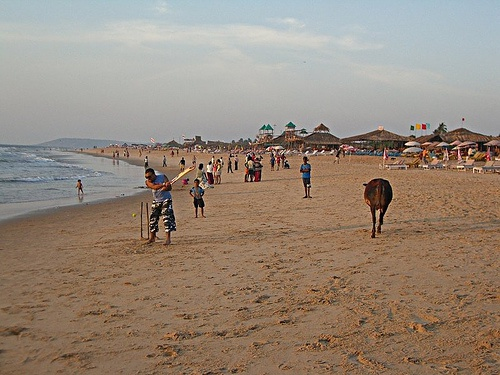Describe the objects in this image and their specific colors. I can see people in lightblue, gray, tan, and darkgray tones, people in lightblue, black, gray, and maroon tones, cow in lightblue, black, maroon, and gray tones, umbrella in lightblue, maroon, gray, and black tones, and people in lightblue, black, gray, and maroon tones in this image. 